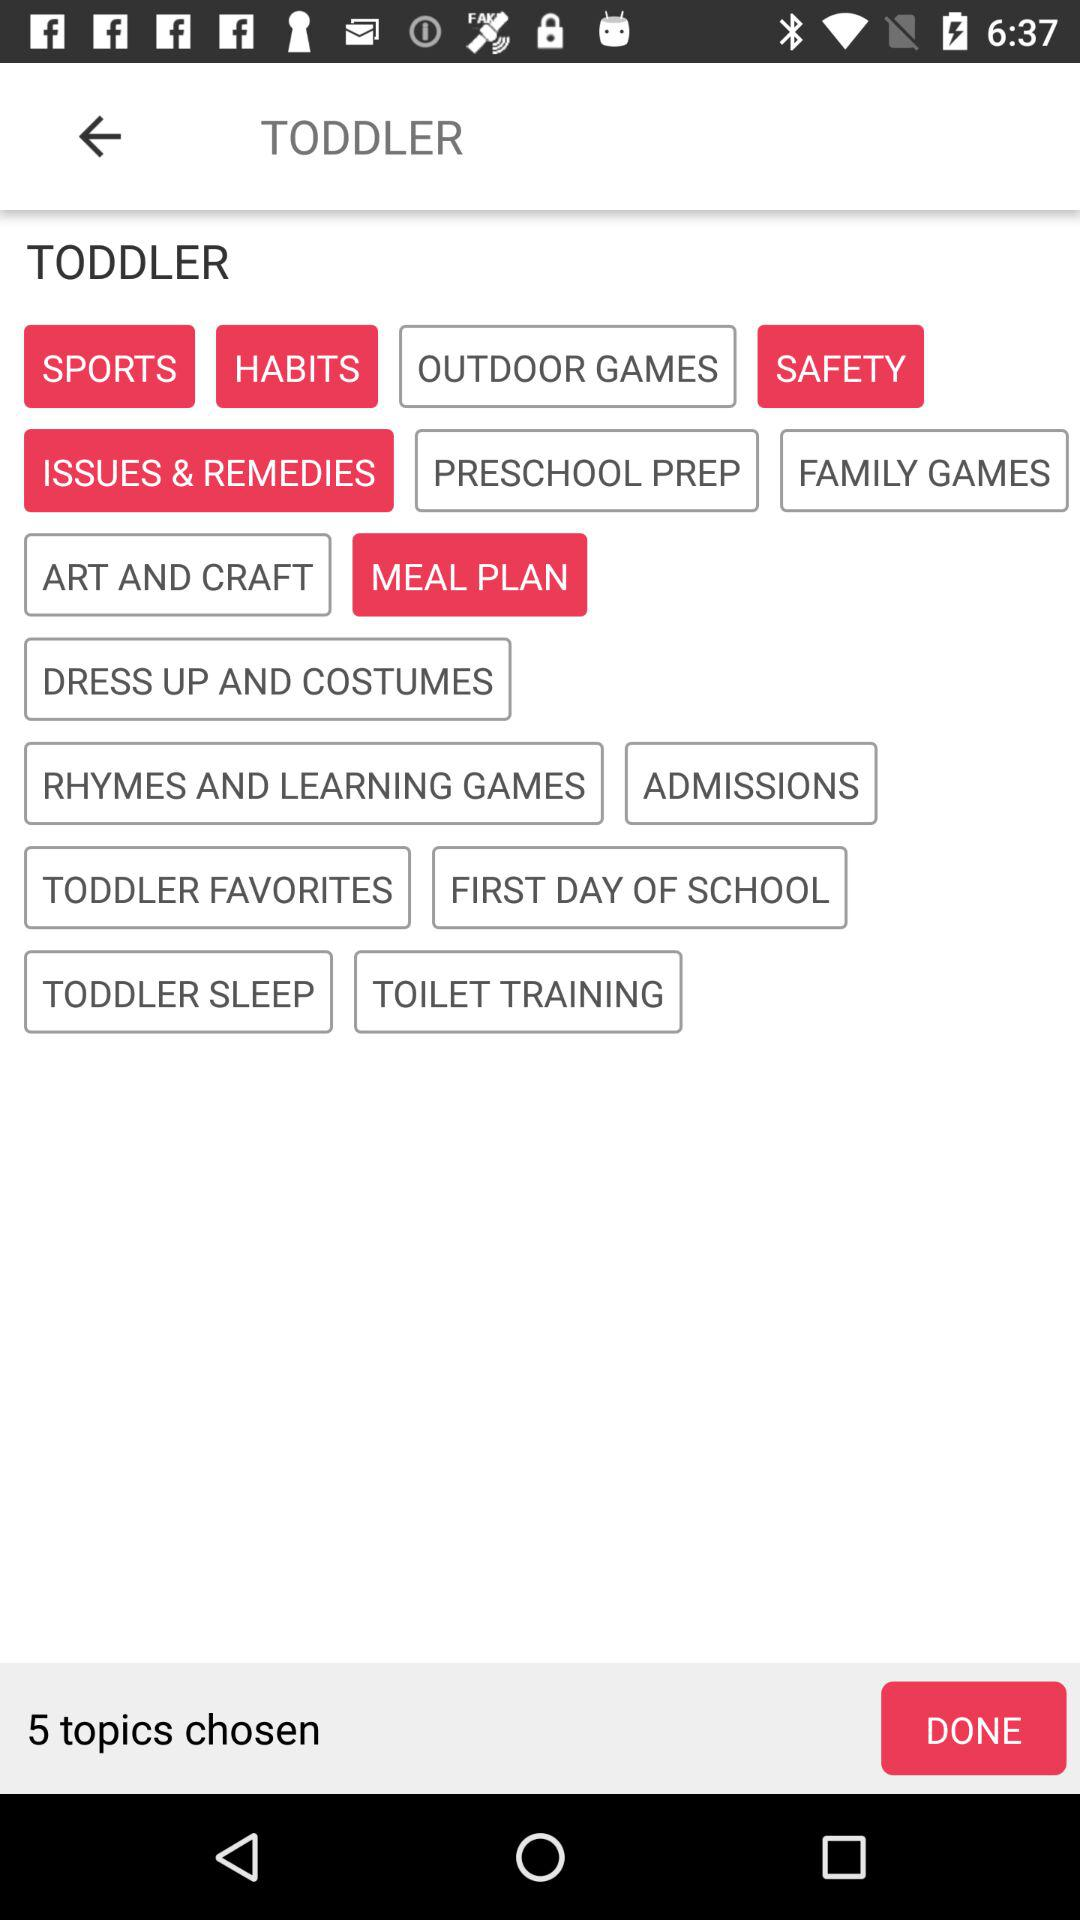How many topics have been chosen?
Answer the question using a single word or phrase. 5 